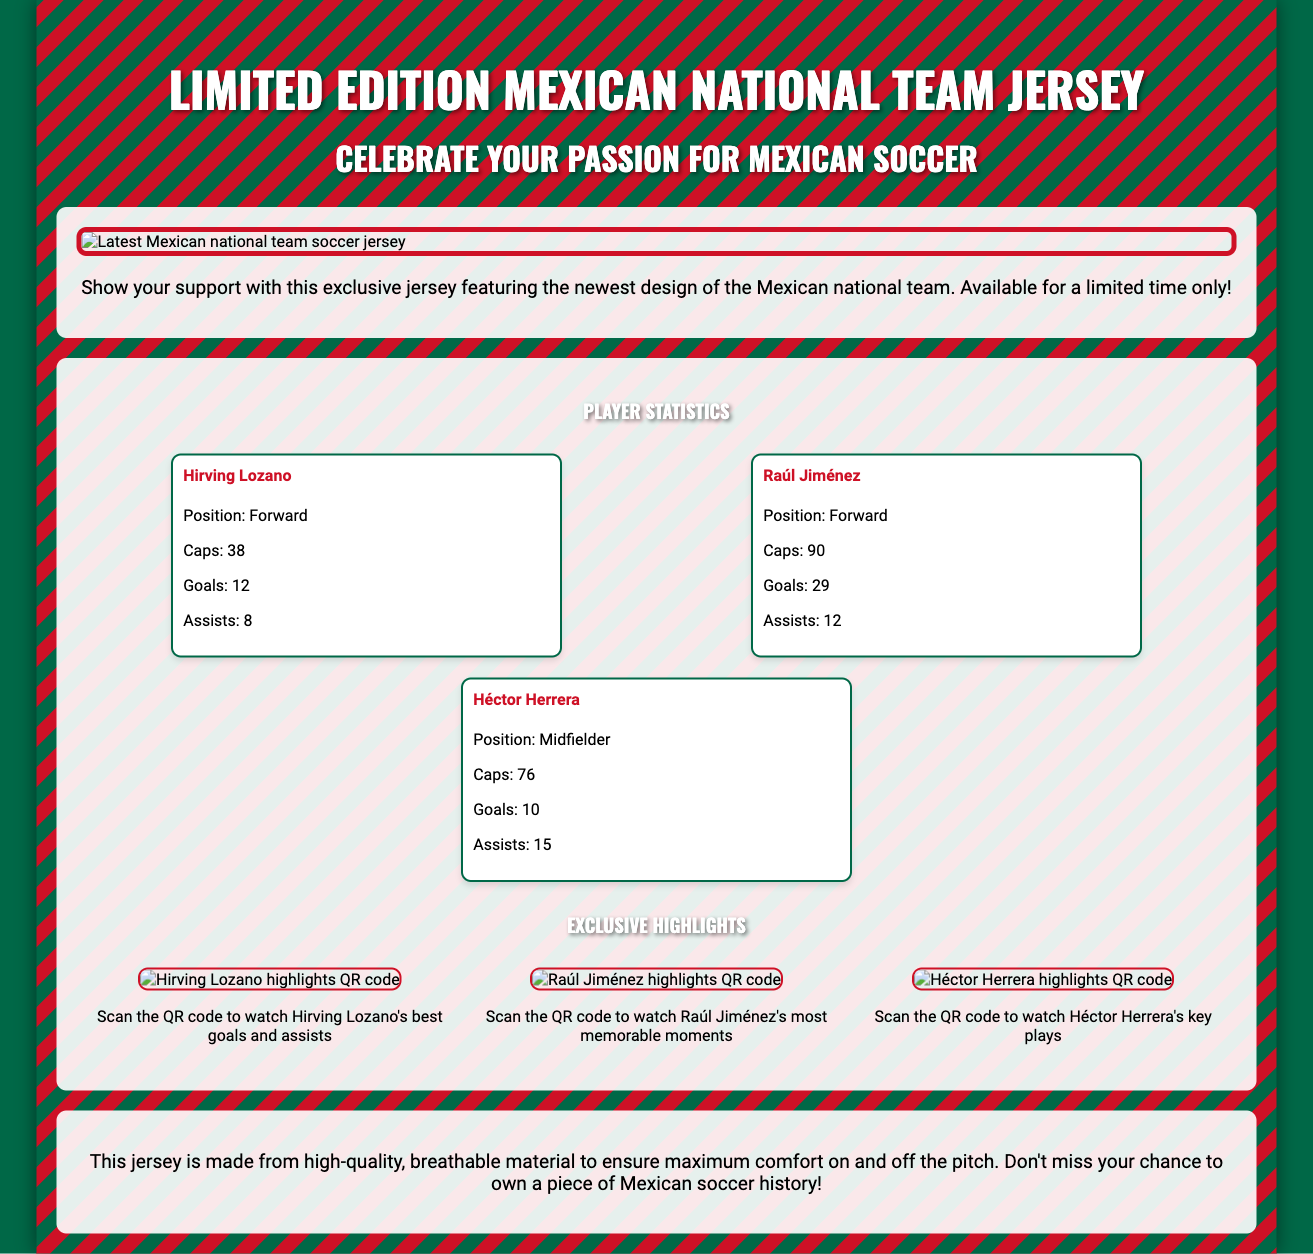What is the title of the document? The title of the document is indicated at the top as "Limited Edition Mexican National Team Jersey."
Answer: Limited Edition Mexican National Team Jersey How many caps does Raúl Jiménez have? The document states that Raúl Jiménez has 90 caps listed under his player statistics.
Answer: 90 What material is the jersey made of? The document mentions that the jersey is made from high-quality, breathable material for comfort.
Answer: Breathable material What is the QR code for Hirving Lozano linked to? The document specifies that scanning Hirving Lozano's QR code allows you to watch his best goals and assists.
Answer: Best goals and assists How many goals has Héctor Herrera scored? According to the player statistics provided, Héctor Herrera has scored 10 goals.
Answer: 10 What does the wrapper feature aside from player statistics? The document highlights that it features QR codes linking to highlight reels, indicating additional content.
Answer: QR codes linking to highlight reels What color scheme is used in the background design of the wrapper? The wrapper exhibits a color scheme blending green and red, reflecting the Mexican national team's colors.
Answer: Green and red What is the main purpose of this limited edition jersey? The document emphasizes the purpose as celebrating passion for Mexican soccer through the limited edition jersey.
Answer: Celebrate your passion for Mexican soccer 